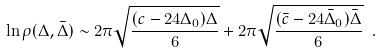<formula> <loc_0><loc_0><loc_500><loc_500>\ln \rho ( \Delta , { \bar { \Delta } } ) \sim 2 \pi \sqrt { \frac { ( c - 2 4 \Delta _ { 0 } ) \Delta } { 6 } } + 2 \pi \sqrt { \frac { ( { \bar { c } } - 2 4 { \bar { \Delta } } _ { 0 } ) { \bar { \Delta } } } { 6 } } \ .</formula> 